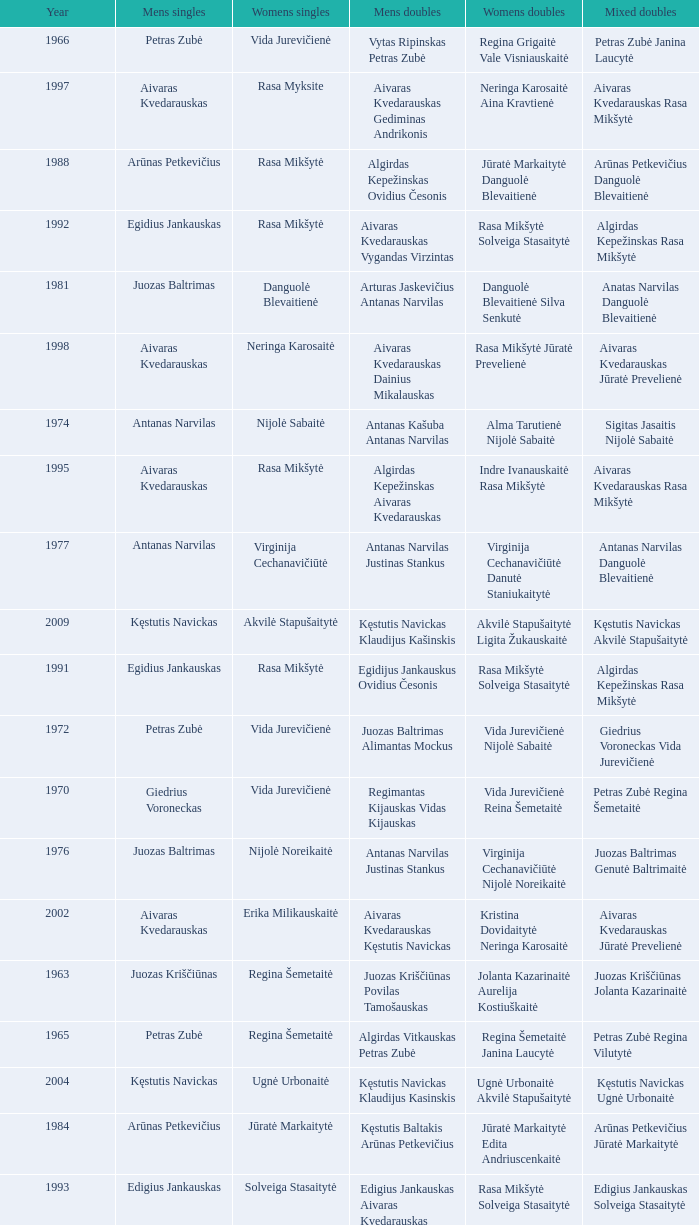How many years did aivaras kvedarauskas juozas spelveris participate in the men's doubles? 1.0. Could you parse the entire table? {'header': ['Year', 'Mens singles', 'Womens singles', 'Mens doubles', 'Womens doubles', 'Mixed doubles'], 'rows': [['1966', 'Petras Zubė', 'Vida Jurevičienė', 'Vytas Ripinskas Petras Zubė', 'Regina Grigaitė Vale Visniauskaitė', 'Petras Zubė Janina Laucytė'], ['1997', 'Aivaras Kvedarauskas', 'Rasa Myksite', 'Aivaras Kvedarauskas Gediminas Andrikonis', 'Neringa Karosaitė Aina Kravtienė', 'Aivaras Kvedarauskas Rasa Mikšytė'], ['1988', 'Arūnas Petkevičius', 'Rasa Mikšytė', 'Algirdas Kepežinskas Ovidius Česonis', 'Jūratė Markaitytė Danguolė Blevaitienė', 'Arūnas Petkevičius Danguolė Blevaitienė'], ['1992', 'Egidius Jankauskas', 'Rasa Mikšytė', 'Aivaras Kvedarauskas Vygandas Virzintas', 'Rasa Mikšytė Solveiga Stasaitytė', 'Algirdas Kepežinskas Rasa Mikšytė'], ['1981', 'Juozas Baltrimas', 'Danguolė Blevaitienė', 'Arturas Jaskevičius Antanas Narvilas', 'Danguolė Blevaitienė Silva Senkutė', 'Anatas Narvilas Danguolė Blevaitienė'], ['1998', 'Aivaras Kvedarauskas', 'Neringa Karosaitė', 'Aivaras Kvedarauskas Dainius Mikalauskas', 'Rasa Mikšytė Jūratė Prevelienė', 'Aivaras Kvedarauskas Jūratė Prevelienė'], ['1974', 'Antanas Narvilas', 'Nijolė Sabaitė', 'Antanas Kašuba Antanas Narvilas', 'Alma Tarutienė Nijolė Sabaitė', 'Sigitas Jasaitis Nijolė Sabaitė'], ['1995', 'Aivaras Kvedarauskas', 'Rasa Mikšytė', 'Algirdas Kepežinskas Aivaras Kvedarauskas', 'Indre Ivanauskaitė Rasa Mikšytė', 'Aivaras Kvedarauskas Rasa Mikšytė'], ['1977', 'Antanas Narvilas', 'Virginija Cechanavičiūtė', 'Antanas Narvilas Justinas Stankus', 'Virginija Cechanavičiūtė Danutė Staniukaitytė', 'Antanas Narvilas Danguolė Blevaitienė'], ['2009', 'Kęstutis Navickas', 'Akvilė Stapušaitytė', 'Kęstutis Navickas Klaudijus Kašinskis', 'Akvilė Stapušaitytė Ligita Žukauskaitė', 'Kęstutis Navickas Akvilė Stapušaitytė'], ['1991', 'Egidius Jankauskas', 'Rasa Mikšytė', 'Egidijus Jankauskus Ovidius Česonis', 'Rasa Mikšytė Solveiga Stasaitytė', 'Algirdas Kepežinskas Rasa Mikšytė'], ['1972', 'Petras Zubė', 'Vida Jurevičienė', 'Juozas Baltrimas Alimantas Mockus', 'Vida Jurevičienė Nijolė Sabaitė', 'Giedrius Voroneckas Vida Jurevičienė'], ['1970', 'Giedrius Voroneckas', 'Vida Jurevičienė', 'Regimantas Kijauskas Vidas Kijauskas', 'Vida Jurevičienė Reina Šemetaitė', 'Petras Zubė Regina Šemetaitė'], ['1976', 'Juozas Baltrimas', 'Nijolė Noreikaitė', 'Antanas Narvilas Justinas Stankus', 'Virginija Cechanavičiūtė Nijolė Noreikaitė', 'Juozas Baltrimas Genutė Baltrimaitė'], ['2002', 'Aivaras Kvedarauskas', 'Erika Milikauskaitė', 'Aivaras Kvedarauskas Kęstutis Navickas', 'Kristina Dovidaitytė Neringa Karosaitė', 'Aivaras Kvedarauskas Jūratė Prevelienė'], ['1963', 'Juozas Kriščiūnas', 'Regina Šemetaitė', 'Juozas Kriščiūnas Povilas Tamošauskas', 'Jolanta Kazarinaitė Aurelija Kostiuškaitė', 'Juozas Kriščiūnas Jolanta Kazarinaitė'], ['1965', 'Petras Zubė', 'Regina Šemetaitė', 'Algirdas Vitkauskas Petras Zubė', 'Regina Šemetaitė Janina Laucytė', 'Petras Zubė Regina Vilutytė'], ['2004', 'Kęstutis Navickas', 'Ugnė Urbonaitė', 'Kęstutis Navickas Klaudijus Kasinskis', 'Ugnė Urbonaitė Akvilė Stapušaitytė', 'Kęstutis Navickas Ugnė Urbonaitė'], ['1984', 'Arūnas Petkevičius', 'Jūratė Markaitytė', 'Kęstutis Baltakis Arūnas Petkevičius', 'Jūratė Markaitytė Edita Andriuscenkaitė', 'Arūnas Petkevičius Jūratė Markaitytė'], ['1993', 'Edigius Jankauskas', 'Solveiga Stasaitytė', 'Edigius Jankauskas Aivaras Kvedarauskas', 'Rasa Mikšytė Solveiga Stasaitytė', 'Edigius Jankauskas Solveiga Stasaitytė'], ['1978', 'Juozas Baltrimas', 'Virginija Cechanavičiūtė', 'Arturas Jaskevičius Justinas Stankus', 'Virginija Cechanavičiūtė Asta Šimbelytė', 'Rimas Liubartas Virginija Cechanavičiūtė'], ['2000', 'Aivaras Kvedarauskas', 'Erika Milikauskaitė', 'Aivaras Kvedarauskas Donatas Vievesis', 'Kristina Dovidaitytė Neringa Karosaitė', 'Aivaras Kvedarauskas Jūratė Prevelienė'], ['1967', 'Juozas Baltrimas', 'Vida Jurevičienė', 'Vytas Ripinskas Petras Zubė', 'Vida Jurevičienė Vale Viniauskaitė', 'Petras Zubė Regina Minelgienė'], ['1979', 'Antanas Narvilas', 'Virginija Cechanavičiūtė', 'Juozas Baltrimas Kęstutis Dabravolskis', 'Virginija Cechanavičiūtė Milda Taraskevičiūtė', 'Juozas Baltrimas Genutė Baltrimaitė'], ['1996', 'Aivaras Kvedarauskas', 'Rasa Myksite', 'Aivaras Kvedarauskas Donatas Vievesis', 'Indre Ivanauskaitė Rasa Mikšytė', 'Aivaras Kvedarauskas Rasa Mikšytė'], ['1975', 'Juozas Baltrimas', 'Nijolė Sabaitė', 'Antanas Narvilas Justinas Stankus', 'Genutė Baltrimaitė Danutė Staniukaitytė', 'Juozas Baltrimas Genutė Baltrimaitė'], ['2003', 'Aivaras Kvedarauskas', 'Ugnė Urbonaitė', 'Aivaras Kvedarauskas Dainius Mikalauskas', 'Ugnė Urbonaitė Kristina Dovidaitytė', 'Aivaras Kvedarauskas Ugnė Urbonaitė'], ['1987', 'Egidijus Jankauskas', 'Jūratė Markaitytė', 'Kęstutis Baltakis Arūnas Petkevičius', 'Jūratė Markaitytė Danguolė Blevaitienė', 'Egidijus Jankauskas Danguolė Blevaitienė'], ['2005', 'Kęstutis Navickas', 'Ugnė Urbonaitė', 'Kęstutis Navickas Klaudijus Kasinskis', 'Ugnė Urbonaitė Akvilė Stapušaitytė', 'Donatas Narvilas Kristina Dovidaitytė'], ['2008', 'Kęstutis Navickas', 'Akvilė Stapušaitytė', 'Paulius Geležiūnas Ramūnas Stapušaitis', 'Gerda Voitechovskaja Kristina Dovidaitytė', 'Kęstutis Navickas Akvilė Stapušaitytė'], ['1969', 'Petras Zubė', 'Valė Viskinauskaitė', 'Antanas Narvilas Regimantas Kijauskas', 'Regina Šemetaitė Salvija Petronytė', 'Petras Zubė Regina Minelgienė'], ['1964', 'Juozas Kriščiūnas', 'Jolanta Kazarinaitė', 'Juozas Kriščiūnas Vladas Rybakovas', 'Jolanta Kazarinaitė Valentina Guseva', 'Vladas Rybakovas Valentina Gusva'], ['1990', 'Aivaras Kvedarauskas', 'Rasa Mikšytė', 'Algirdas Kepežinskas Ovidius Česonis', 'Jūratė Markaitytė Danguolė Blevaitienė', 'Aivaras Kvedarauskas Rasa Mikšytė'], ['1985', 'Arūnas Petkevičius', 'Jūratė Markaitytė', 'Kęstutis Baltakis Arūnas Petkevičius', 'Jūratė Markaitytė Silva Senkutė', 'Arūnas Petkevičius Jūratė Markaitytė'], ['2007', 'Kęstutis Navickas', 'Akvilė Stapušaitytė', 'Kęstutis Navickas Klaudijus Kašinskis', 'Gerda Voitechovskaja Kristina Dovidaitytė', 'Kęstutis Navickas Indrė Starevičiūtė'], ['1982', 'Juozas Baltrimas', 'Danguolė Blevaitienė', 'Juozas Baltrimas Sigitas Jasaitis', 'Danguolė Blevaitienė Silva Senkutė', 'Anatas Narvilas Danguolė Blevaitienė'], ['1980', 'Arturas Jaskevičius', 'Milda Taraskevičiūtė', 'Juozas Baltrimas Kęstutis Baltakis', 'Asta Šimbelytė Milda Taraskevičiūtė', 'Sigitas Jasaitis Silva Senkutė'], ['1989', 'Ovidijus Cesonis', 'Aušrinė Gabrenaitė', 'Egidijus Jankauskus Ovidius Česonis', 'Aušrinė Gebranaitė Rasa Mikšytė', 'Egidijus Jankauskas Aušrinė Gabrenaitė'], ['1973', 'Juozas Baltrimas', 'Nijolė Sabaitė', 'Antanas Kašuba Petras Zubė', 'Danutė Staniukaitytė Nijolė Sabaitė', 'Petras Zubė Drazina Dovidavičiūtė'], ['1994', 'Aivaras Kvedarauskas', 'Aina Kravtienė', 'Aivaras Kvedarauskas Ovidijus Zukauskas', 'Indre Ivanauskaitė Rasa Mikšytė', 'Aivaras Kvedarauskas Indze Ivanauskaitė'], ['1968', 'Juozas Baltrimas', 'Vida Jurevičienė', 'Juozas Kriščiūnas Petras Zubė', 'Vida Jurevičienė Undinė Jagelaitė', 'Juozas Kriščiūnas Vida Jurevičienė'], ['1999', 'Aivaras Kvedarauskas', 'Erika Milikauskaitė', 'Aivaras Kvedarauskas Dainius Mikalauskas', 'Rasa Mikšytė Jūratė Prevelienė', 'Aivaras Kvedarauskas Rasa Mikšytė'], ['1971', 'Petras Zubė', 'Vida Jurevičienė', 'Antanas Narvilas Petras Zubė', 'Vida Jurevičienė Undinė Jagelaitė', 'Petras Zubė Regina Šemetaitė'], ['2006', 'Šarūnas Bilius', 'Akvilė Stapušaitytė', 'Deividas Butkus Klaudijus Kašinskis', 'Akvilė Stapušaitytė Ligita Žukauskaitė', 'Donatas Narvilas Kristina Dovidaitytė'], ['1983', 'Arūnas Petkevičius', 'Jūratė Markaitytė', 'Kęstutis Baltakis Arūnas Petkevičius', 'Jūratė Markaitytė Jūratė Lazauninkaitė', 'Kstutis Baltakis Jūratė Andriuscenkaitė'], ['1986', 'Arūnas Petkevičius', 'Jūratė Markaitytė', 'Kęstutis Baltakis Arūnas Petkevičius', 'Jūratė Markaitytė Aušrinė Gebranaitė', 'Egidijus Jankauskas Jūratė Markaitytė'], ['2001', 'Aivaras Kvedarauskas', 'Neringa Karosaitė', 'Aivaras Kvedarauskas Juozas Spelveris', 'Kristina Dovidaitytė Neringa Karosaitė', 'Aivaras Kvedarauskas Ligita Zakauskaitė']]} 